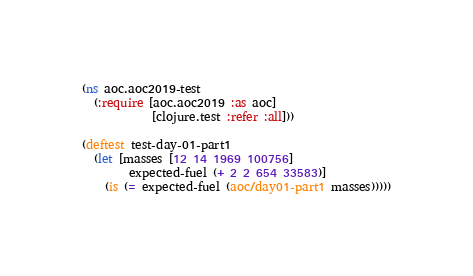Convert code to text. <code><loc_0><loc_0><loc_500><loc_500><_Clojure_>(ns aoc.aoc2019-test
  (:require [aoc.aoc2019 :as aoc]
            [clojure.test :refer :all]))

(deftest test-day-01-part1
  (let [masses [12 14 1969 100756]
        expected-fuel (+ 2 2 654 33583)]
    (is (= expected-fuel (aoc/day01-part1 masses)))))
</code> 